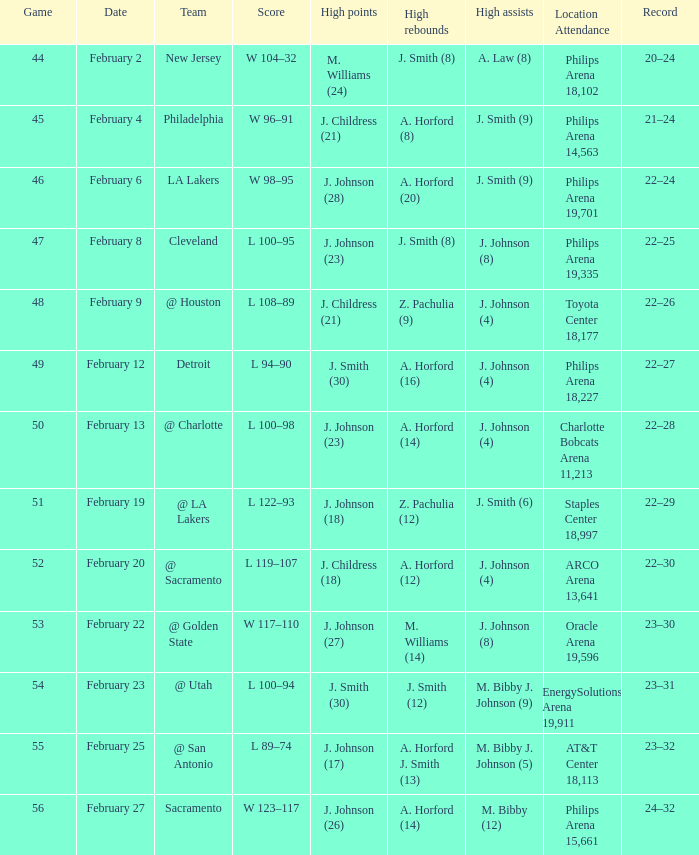What is the team located at philips arena 18,227? Detroit. 